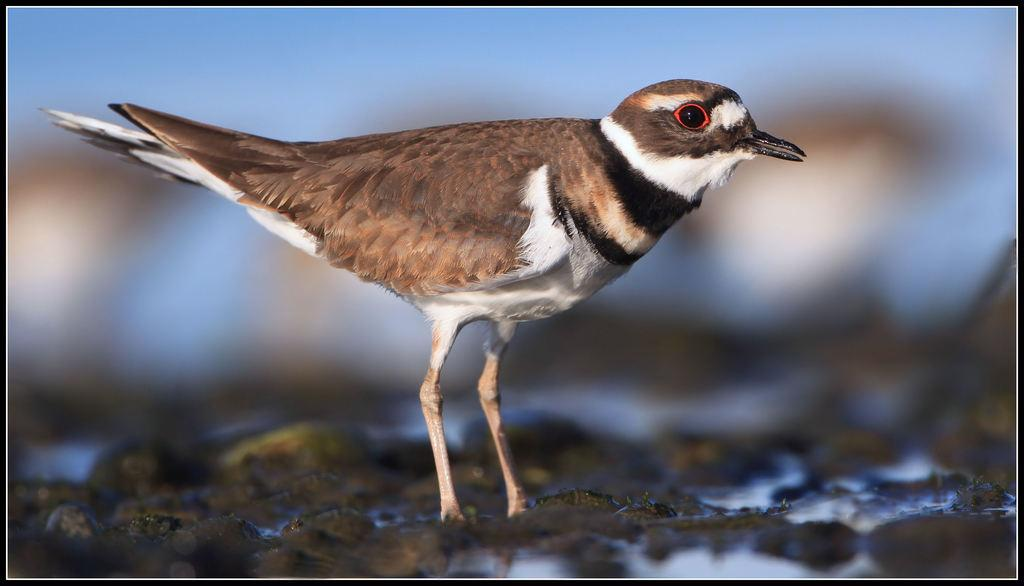What type of animal is in the image? There is a bird in the image. What is the bird standing on? The bird is on a mud surface. Is there any water visible in the image? Yes, there is water on the surface. What colors can be seen on the bird? The bird is brown in color with white shades. What feature is present on the bird's face? The bird has a beak. What type of vest is the bird wearing in the image? There is no vest present on the bird in the image. What boundary is visible in the image? There is no boundary visible in the image; it features a bird on a mud surface with water. 